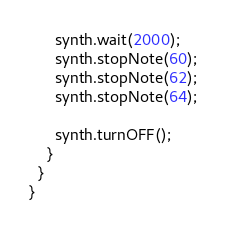<code> <loc_0><loc_0><loc_500><loc_500><_Java_>      synth.wait(2000);
      synth.stopNote(60);
      synth.stopNote(62);
      synth.stopNote(64);

      synth.turnOFF();
    }
  }
}</code> 